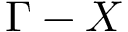<formula> <loc_0><loc_0><loc_500><loc_500>\Gamma - X</formula> 